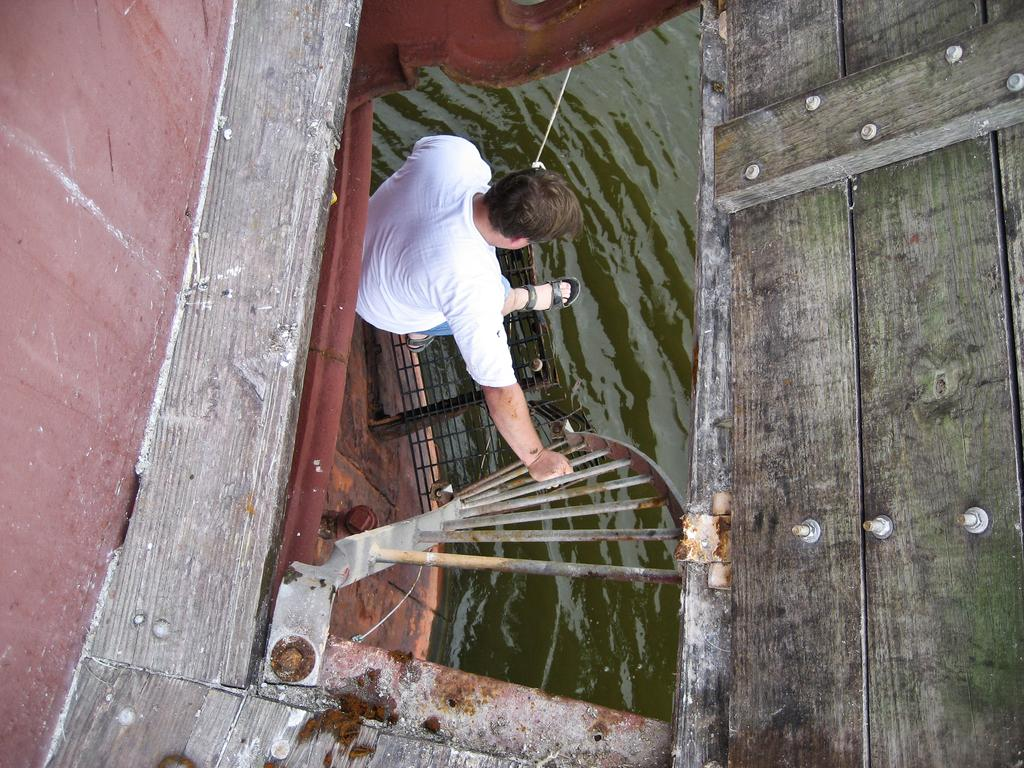What is the person in the image doing? The person is on the steps in the image. What can be seen in the image besides the person? There is a fence and a wall visible in the image. What is the background of the image like? There is water visible in the background of the image, and there is a wooden fence in the background as well. When do you think the image was taken? The image was likely taken during the day, as the lighting suggests. Is the person wearing a veil in the image? There is no veil visible on the person in the image. What observation can be made about the person's behavior in the image? The image does not provide enough information to make any observations about the person's behavior. 